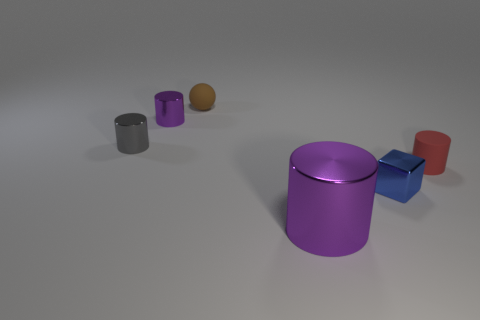Is there another thing of the same color as the big shiny thing?
Keep it short and to the point. Yes. There is a object that is the same color as the large metal cylinder; what is its size?
Make the answer very short. Small. There is a blue metal object that is the same size as the gray shiny object; what is its shape?
Your answer should be very brief. Cube. What is the material of the tiny object that is the same color as the large cylinder?
Your response must be concise. Metal. There is a object that is both behind the gray cylinder and on the left side of the small brown thing; what size is it?
Provide a succinct answer. Small. How many shiny things are purple objects or small blue blocks?
Keep it short and to the point. 3. Are there more tiny red things that are behind the tiny gray shiny thing than small green metal things?
Give a very brief answer. No. What is the purple thing that is left of the brown thing made of?
Keep it short and to the point. Metal. What number of small purple cylinders have the same material as the big purple cylinder?
Ensure brevity in your answer.  1. The tiny metal object that is both to the right of the small gray metal object and left of the tiny brown rubber thing has what shape?
Give a very brief answer. Cylinder. 